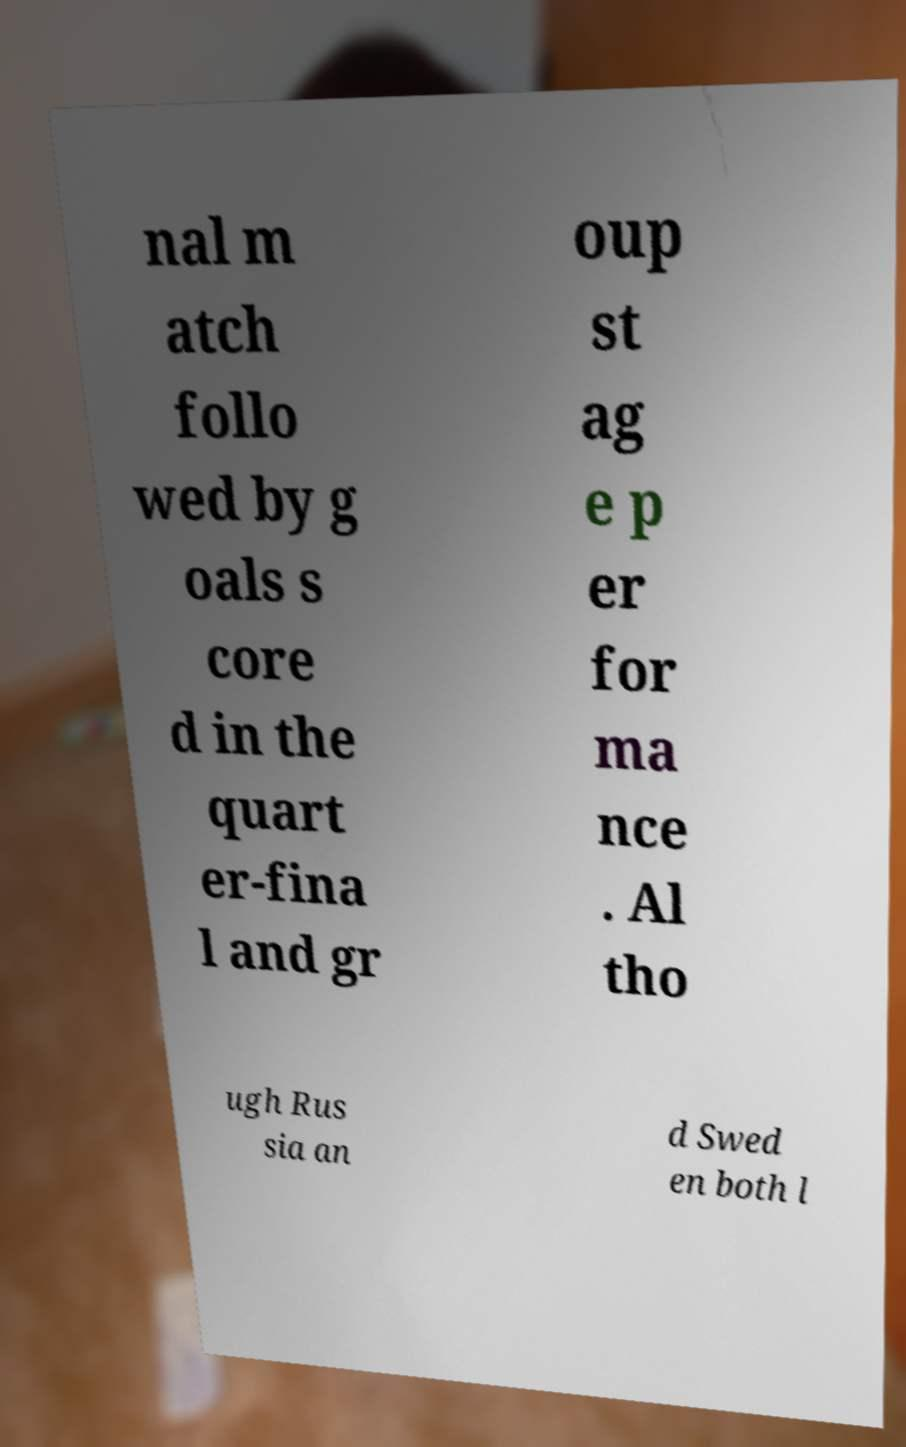I need the written content from this picture converted into text. Can you do that? nal m atch follo wed by g oals s core d in the quart er-fina l and gr oup st ag e p er for ma nce . Al tho ugh Rus sia an d Swed en both l 